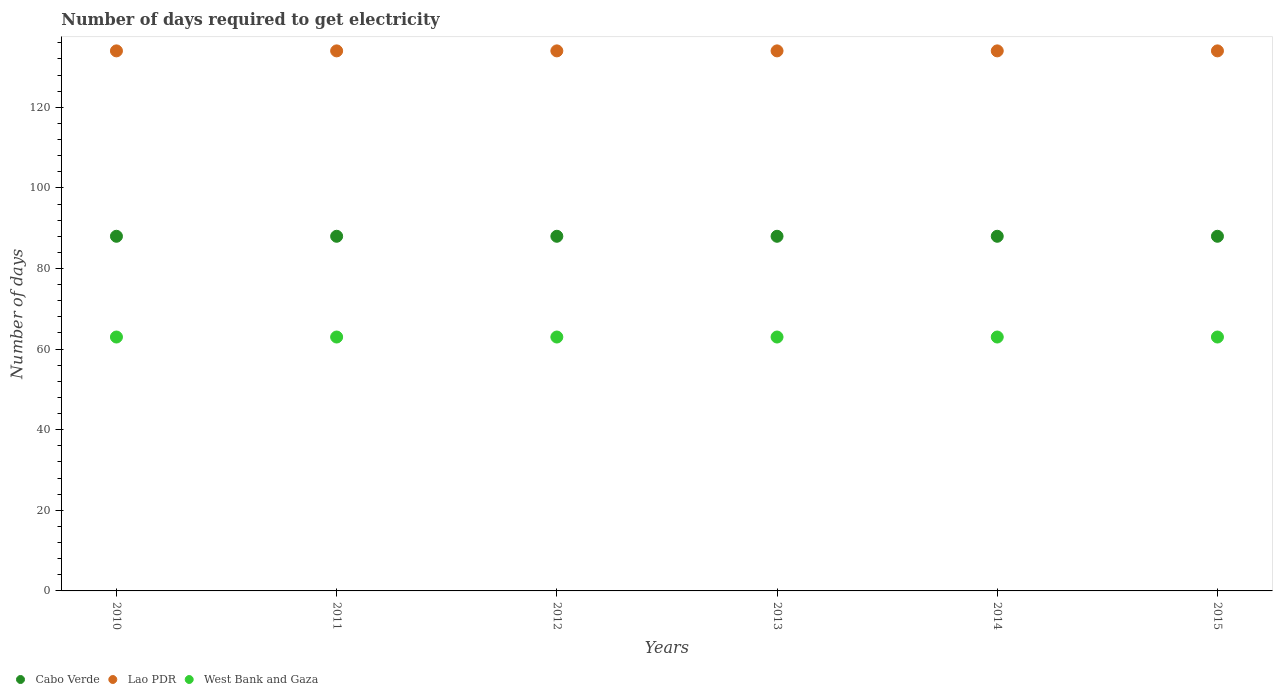How many different coloured dotlines are there?
Your response must be concise. 3. Is the number of dotlines equal to the number of legend labels?
Offer a very short reply. Yes. What is the number of days required to get electricity in in Cabo Verde in 2011?
Offer a very short reply. 88. Across all years, what is the maximum number of days required to get electricity in in West Bank and Gaza?
Offer a very short reply. 63. Across all years, what is the minimum number of days required to get electricity in in Lao PDR?
Give a very brief answer. 134. In which year was the number of days required to get electricity in in West Bank and Gaza maximum?
Provide a succinct answer. 2010. In which year was the number of days required to get electricity in in Lao PDR minimum?
Ensure brevity in your answer.  2010. What is the total number of days required to get electricity in in West Bank and Gaza in the graph?
Provide a short and direct response. 378. What is the difference between the number of days required to get electricity in in Lao PDR in 2010 and that in 2013?
Your answer should be very brief. 0. What is the difference between the number of days required to get electricity in in Cabo Verde in 2015 and the number of days required to get electricity in in West Bank and Gaza in 2013?
Your answer should be very brief. 25. What is the average number of days required to get electricity in in Lao PDR per year?
Your answer should be compact. 134. In the year 2015, what is the difference between the number of days required to get electricity in in West Bank and Gaza and number of days required to get electricity in in Cabo Verde?
Offer a very short reply. -25. What is the ratio of the number of days required to get electricity in in West Bank and Gaza in 2013 to that in 2015?
Give a very brief answer. 1. What is the difference between the highest and the second highest number of days required to get electricity in in West Bank and Gaza?
Provide a succinct answer. 0. In how many years, is the number of days required to get electricity in in West Bank and Gaza greater than the average number of days required to get electricity in in West Bank and Gaza taken over all years?
Your answer should be compact. 0. Is it the case that in every year, the sum of the number of days required to get electricity in in Lao PDR and number of days required to get electricity in in Cabo Verde  is greater than the number of days required to get electricity in in West Bank and Gaza?
Offer a terse response. Yes. Is the number of days required to get electricity in in Cabo Verde strictly less than the number of days required to get electricity in in Lao PDR over the years?
Make the answer very short. Yes. Does the graph contain any zero values?
Your answer should be compact. No. Where does the legend appear in the graph?
Ensure brevity in your answer.  Bottom left. How many legend labels are there?
Your response must be concise. 3. How are the legend labels stacked?
Your answer should be very brief. Horizontal. What is the title of the graph?
Offer a terse response. Number of days required to get electricity. Does "Brazil" appear as one of the legend labels in the graph?
Make the answer very short. No. What is the label or title of the X-axis?
Provide a short and direct response. Years. What is the label or title of the Y-axis?
Provide a short and direct response. Number of days. What is the Number of days of Lao PDR in 2010?
Your answer should be compact. 134. What is the Number of days of Cabo Verde in 2011?
Your answer should be compact. 88. What is the Number of days in Lao PDR in 2011?
Provide a succinct answer. 134. What is the Number of days in Lao PDR in 2012?
Your response must be concise. 134. What is the Number of days in Cabo Verde in 2013?
Ensure brevity in your answer.  88. What is the Number of days in Lao PDR in 2013?
Your answer should be very brief. 134. What is the Number of days in Cabo Verde in 2014?
Your answer should be very brief. 88. What is the Number of days in Lao PDR in 2014?
Your answer should be compact. 134. What is the Number of days in Cabo Verde in 2015?
Provide a short and direct response. 88. What is the Number of days in Lao PDR in 2015?
Give a very brief answer. 134. What is the Number of days of West Bank and Gaza in 2015?
Keep it short and to the point. 63. Across all years, what is the maximum Number of days in Cabo Verde?
Your answer should be very brief. 88. Across all years, what is the maximum Number of days in Lao PDR?
Provide a succinct answer. 134. Across all years, what is the minimum Number of days in Cabo Verde?
Make the answer very short. 88. Across all years, what is the minimum Number of days in Lao PDR?
Ensure brevity in your answer.  134. What is the total Number of days of Cabo Verde in the graph?
Make the answer very short. 528. What is the total Number of days of Lao PDR in the graph?
Your response must be concise. 804. What is the total Number of days in West Bank and Gaza in the graph?
Keep it short and to the point. 378. What is the difference between the Number of days of West Bank and Gaza in 2010 and that in 2012?
Ensure brevity in your answer.  0. What is the difference between the Number of days in Cabo Verde in 2010 and that in 2013?
Make the answer very short. 0. What is the difference between the Number of days of Lao PDR in 2010 and that in 2013?
Your answer should be very brief. 0. What is the difference between the Number of days of Cabo Verde in 2010 and that in 2014?
Keep it short and to the point. 0. What is the difference between the Number of days in West Bank and Gaza in 2010 and that in 2014?
Provide a succinct answer. 0. What is the difference between the Number of days of Lao PDR in 2010 and that in 2015?
Your response must be concise. 0. What is the difference between the Number of days of West Bank and Gaza in 2010 and that in 2015?
Offer a very short reply. 0. What is the difference between the Number of days in Lao PDR in 2011 and that in 2012?
Provide a short and direct response. 0. What is the difference between the Number of days of West Bank and Gaza in 2011 and that in 2012?
Your response must be concise. 0. What is the difference between the Number of days of Cabo Verde in 2011 and that in 2013?
Keep it short and to the point. 0. What is the difference between the Number of days in Lao PDR in 2011 and that in 2014?
Provide a succinct answer. 0. What is the difference between the Number of days in West Bank and Gaza in 2011 and that in 2014?
Give a very brief answer. 0. What is the difference between the Number of days of Cabo Verde in 2011 and that in 2015?
Offer a very short reply. 0. What is the difference between the Number of days in Cabo Verde in 2012 and that in 2013?
Keep it short and to the point. 0. What is the difference between the Number of days of Lao PDR in 2012 and that in 2013?
Provide a short and direct response. 0. What is the difference between the Number of days in Cabo Verde in 2012 and that in 2014?
Give a very brief answer. 0. What is the difference between the Number of days of West Bank and Gaza in 2012 and that in 2014?
Ensure brevity in your answer.  0. What is the difference between the Number of days of Lao PDR in 2012 and that in 2015?
Give a very brief answer. 0. What is the difference between the Number of days in West Bank and Gaza in 2012 and that in 2015?
Provide a succinct answer. 0. What is the difference between the Number of days of Lao PDR in 2013 and that in 2014?
Make the answer very short. 0. What is the difference between the Number of days in West Bank and Gaza in 2013 and that in 2014?
Offer a terse response. 0. What is the difference between the Number of days of Lao PDR in 2013 and that in 2015?
Provide a succinct answer. 0. What is the difference between the Number of days of Cabo Verde in 2014 and that in 2015?
Provide a succinct answer. 0. What is the difference between the Number of days of Cabo Verde in 2010 and the Number of days of Lao PDR in 2011?
Your response must be concise. -46. What is the difference between the Number of days in Cabo Verde in 2010 and the Number of days in West Bank and Gaza in 2011?
Keep it short and to the point. 25. What is the difference between the Number of days of Cabo Verde in 2010 and the Number of days of Lao PDR in 2012?
Provide a short and direct response. -46. What is the difference between the Number of days in Lao PDR in 2010 and the Number of days in West Bank and Gaza in 2012?
Your response must be concise. 71. What is the difference between the Number of days in Cabo Verde in 2010 and the Number of days in Lao PDR in 2013?
Ensure brevity in your answer.  -46. What is the difference between the Number of days in Cabo Verde in 2010 and the Number of days in West Bank and Gaza in 2013?
Provide a short and direct response. 25. What is the difference between the Number of days in Lao PDR in 2010 and the Number of days in West Bank and Gaza in 2013?
Give a very brief answer. 71. What is the difference between the Number of days of Cabo Verde in 2010 and the Number of days of Lao PDR in 2014?
Provide a succinct answer. -46. What is the difference between the Number of days of Cabo Verde in 2010 and the Number of days of West Bank and Gaza in 2014?
Your answer should be compact. 25. What is the difference between the Number of days in Cabo Verde in 2010 and the Number of days in Lao PDR in 2015?
Offer a terse response. -46. What is the difference between the Number of days of Cabo Verde in 2010 and the Number of days of West Bank and Gaza in 2015?
Your response must be concise. 25. What is the difference between the Number of days of Lao PDR in 2010 and the Number of days of West Bank and Gaza in 2015?
Your response must be concise. 71. What is the difference between the Number of days of Cabo Verde in 2011 and the Number of days of Lao PDR in 2012?
Ensure brevity in your answer.  -46. What is the difference between the Number of days in Cabo Verde in 2011 and the Number of days in Lao PDR in 2013?
Keep it short and to the point. -46. What is the difference between the Number of days in Lao PDR in 2011 and the Number of days in West Bank and Gaza in 2013?
Provide a succinct answer. 71. What is the difference between the Number of days of Cabo Verde in 2011 and the Number of days of Lao PDR in 2014?
Keep it short and to the point. -46. What is the difference between the Number of days of Cabo Verde in 2011 and the Number of days of Lao PDR in 2015?
Your answer should be compact. -46. What is the difference between the Number of days of Lao PDR in 2011 and the Number of days of West Bank and Gaza in 2015?
Make the answer very short. 71. What is the difference between the Number of days of Cabo Verde in 2012 and the Number of days of Lao PDR in 2013?
Provide a succinct answer. -46. What is the difference between the Number of days of Cabo Verde in 2012 and the Number of days of Lao PDR in 2014?
Provide a succinct answer. -46. What is the difference between the Number of days of Cabo Verde in 2012 and the Number of days of Lao PDR in 2015?
Offer a terse response. -46. What is the difference between the Number of days of Cabo Verde in 2012 and the Number of days of West Bank and Gaza in 2015?
Your response must be concise. 25. What is the difference between the Number of days in Cabo Verde in 2013 and the Number of days in Lao PDR in 2014?
Your response must be concise. -46. What is the difference between the Number of days of Cabo Verde in 2013 and the Number of days of West Bank and Gaza in 2014?
Offer a terse response. 25. What is the difference between the Number of days in Lao PDR in 2013 and the Number of days in West Bank and Gaza in 2014?
Provide a succinct answer. 71. What is the difference between the Number of days in Cabo Verde in 2013 and the Number of days in Lao PDR in 2015?
Ensure brevity in your answer.  -46. What is the difference between the Number of days in Cabo Verde in 2013 and the Number of days in West Bank and Gaza in 2015?
Your answer should be compact. 25. What is the difference between the Number of days in Lao PDR in 2013 and the Number of days in West Bank and Gaza in 2015?
Offer a terse response. 71. What is the difference between the Number of days in Cabo Verde in 2014 and the Number of days in Lao PDR in 2015?
Provide a succinct answer. -46. What is the difference between the Number of days in Cabo Verde in 2014 and the Number of days in West Bank and Gaza in 2015?
Give a very brief answer. 25. What is the difference between the Number of days of Lao PDR in 2014 and the Number of days of West Bank and Gaza in 2015?
Give a very brief answer. 71. What is the average Number of days in Cabo Verde per year?
Ensure brevity in your answer.  88. What is the average Number of days of Lao PDR per year?
Your answer should be very brief. 134. What is the average Number of days in West Bank and Gaza per year?
Your answer should be very brief. 63. In the year 2010, what is the difference between the Number of days of Cabo Verde and Number of days of Lao PDR?
Keep it short and to the point. -46. In the year 2010, what is the difference between the Number of days in Cabo Verde and Number of days in West Bank and Gaza?
Ensure brevity in your answer.  25. In the year 2010, what is the difference between the Number of days in Lao PDR and Number of days in West Bank and Gaza?
Your response must be concise. 71. In the year 2011, what is the difference between the Number of days of Cabo Verde and Number of days of Lao PDR?
Make the answer very short. -46. In the year 2011, what is the difference between the Number of days in Cabo Verde and Number of days in West Bank and Gaza?
Give a very brief answer. 25. In the year 2012, what is the difference between the Number of days of Cabo Verde and Number of days of Lao PDR?
Make the answer very short. -46. In the year 2012, what is the difference between the Number of days of Lao PDR and Number of days of West Bank and Gaza?
Your response must be concise. 71. In the year 2013, what is the difference between the Number of days of Cabo Verde and Number of days of Lao PDR?
Provide a succinct answer. -46. In the year 2013, what is the difference between the Number of days in Cabo Verde and Number of days in West Bank and Gaza?
Your response must be concise. 25. In the year 2013, what is the difference between the Number of days of Lao PDR and Number of days of West Bank and Gaza?
Your response must be concise. 71. In the year 2014, what is the difference between the Number of days in Cabo Verde and Number of days in Lao PDR?
Your response must be concise. -46. In the year 2015, what is the difference between the Number of days in Cabo Verde and Number of days in Lao PDR?
Make the answer very short. -46. In the year 2015, what is the difference between the Number of days of Lao PDR and Number of days of West Bank and Gaza?
Offer a very short reply. 71. What is the ratio of the Number of days in Cabo Verde in 2010 to that in 2011?
Your answer should be compact. 1. What is the ratio of the Number of days in West Bank and Gaza in 2010 to that in 2011?
Give a very brief answer. 1. What is the ratio of the Number of days of West Bank and Gaza in 2010 to that in 2012?
Make the answer very short. 1. What is the ratio of the Number of days in Lao PDR in 2010 to that in 2013?
Your answer should be very brief. 1. What is the ratio of the Number of days in Cabo Verde in 2010 to that in 2014?
Ensure brevity in your answer.  1. What is the ratio of the Number of days of Lao PDR in 2010 to that in 2014?
Give a very brief answer. 1. What is the ratio of the Number of days in West Bank and Gaza in 2010 to that in 2014?
Make the answer very short. 1. What is the ratio of the Number of days in Cabo Verde in 2010 to that in 2015?
Offer a very short reply. 1. What is the ratio of the Number of days of Lao PDR in 2010 to that in 2015?
Your answer should be compact. 1. What is the ratio of the Number of days in West Bank and Gaza in 2010 to that in 2015?
Give a very brief answer. 1. What is the ratio of the Number of days of Cabo Verde in 2011 to that in 2012?
Your answer should be very brief. 1. What is the ratio of the Number of days in Lao PDR in 2011 to that in 2012?
Provide a succinct answer. 1. What is the ratio of the Number of days in Cabo Verde in 2011 to that in 2013?
Give a very brief answer. 1. What is the ratio of the Number of days of West Bank and Gaza in 2011 to that in 2013?
Your answer should be compact. 1. What is the ratio of the Number of days in Cabo Verde in 2011 to that in 2014?
Give a very brief answer. 1. What is the ratio of the Number of days in Cabo Verde in 2012 to that in 2013?
Make the answer very short. 1. What is the ratio of the Number of days of Lao PDR in 2012 to that in 2013?
Offer a terse response. 1. What is the ratio of the Number of days of West Bank and Gaza in 2012 to that in 2013?
Keep it short and to the point. 1. What is the ratio of the Number of days of Lao PDR in 2012 to that in 2014?
Provide a short and direct response. 1. What is the ratio of the Number of days of West Bank and Gaza in 2012 to that in 2014?
Ensure brevity in your answer.  1. What is the ratio of the Number of days in Lao PDR in 2012 to that in 2015?
Ensure brevity in your answer.  1. What is the ratio of the Number of days of West Bank and Gaza in 2012 to that in 2015?
Make the answer very short. 1. What is the ratio of the Number of days of Cabo Verde in 2013 to that in 2014?
Give a very brief answer. 1. What is the ratio of the Number of days of Lao PDR in 2013 to that in 2014?
Your answer should be compact. 1. What is the ratio of the Number of days in Lao PDR in 2013 to that in 2015?
Keep it short and to the point. 1. What is the ratio of the Number of days of Cabo Verde in 2014 to that in 2015?
Offer a terse response. 1. What is the ratio of the Number of days in West Bank and Gaza in 2014 to that in 2015?
Keep it short and to the point. 1. What is the difference between the highest and the lowest Number of days in Cabo Verde?
Provide a short and direct response. 0. What is the difference between the highest and the lowest Number of days of West Bank and Gaza?
Your answer should be compact. 0. 